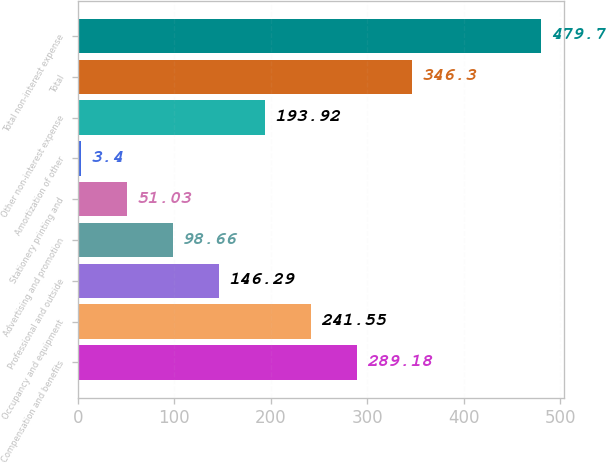Convert chart. <chart><loc_0><loc_0><loc_500><loc_500><bar_chart><fcel>Compensation and benefits<fcel>Occupancy and equipment<fcel>Professional and outside<fcel>Advertising and promotion<fcel>Stationery printing and<fcel>Amortization of other<fcel>Other non-interest expense<fcel>Total<fcel>Total non-interest expense<nl><fcel>289.18<fcel>241.55<fcel>146.29<fcel>98.66<fcel>51.03<fcel>3.4<fcel>193.92<fcel>346.3<fcel>479.7<nl></chart> 